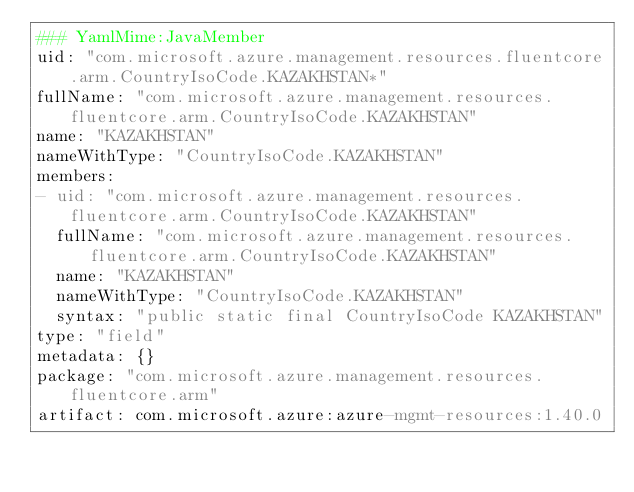Convert code to text. <code><loc_0><loc_0><loc_500><loc_500><_YAML_>### YamlMime:JavaMember
uid: "com.microsoft.azure.management.resources.fluentcore.arm.CountryIsoCode.KAZAKHSTAN*"
fullName: "com.microsoft.azure.management.resources.fluentcore.arm.CountryIsoCode.KAZAKHSTAN"
name: "KAZAKHSTAN"
nameWithType: "CountryIsoCode.KAZAKHSTAN"
members:
- uid: "com.microsoft.azure.management.resources.fluentcore.arm.CountryIsoCode.KAZAKHSTAN"
  fullName: "com.microsoft.azure.management.resources.fluentcore.arm.CountryIsoCode.KAZAKHSTAN"
  name: "KAZAKHSTAN"
  nameWithType: "CountryIsoCode.KAZAKHSTAN"
  syntax: "public static final CountryIsoCode KAZAKHSTAN"
type: "field"
metadata: {}
package: "com.microsoft.azure.management.resources.fluentcore.arm"
artifact: com.microsoft.azure:azure-mgmt-resources:1.40.0
</code> 